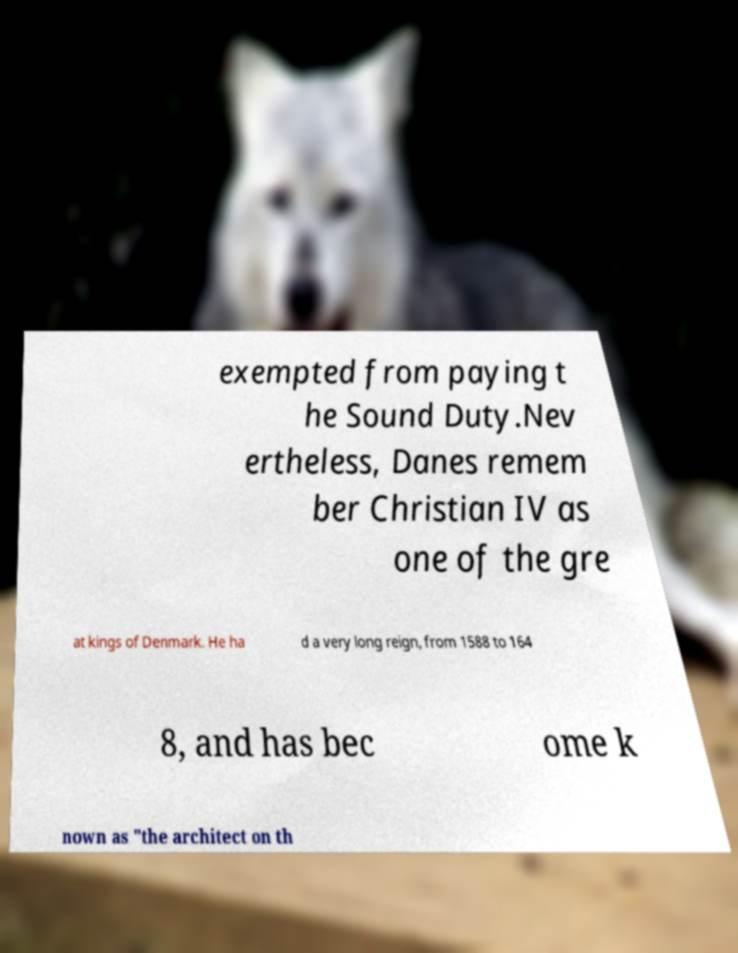I need the written content from this picture converted into text. Can you do that? exempted from paying t he Sound Duty.Nev ertheless, Danes remem ber Christian IV as one of the gre at kings of Denmark. He ha d a very long reign, from 1588 to 164 8, and has bec ome k nown as "the architect on th 